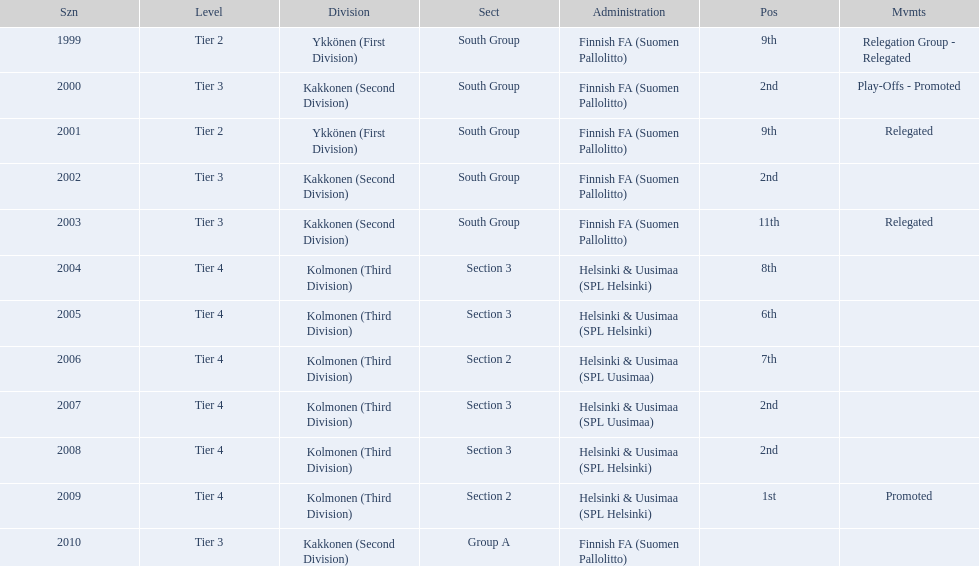When was the last year they placed 2nd? 2008. 